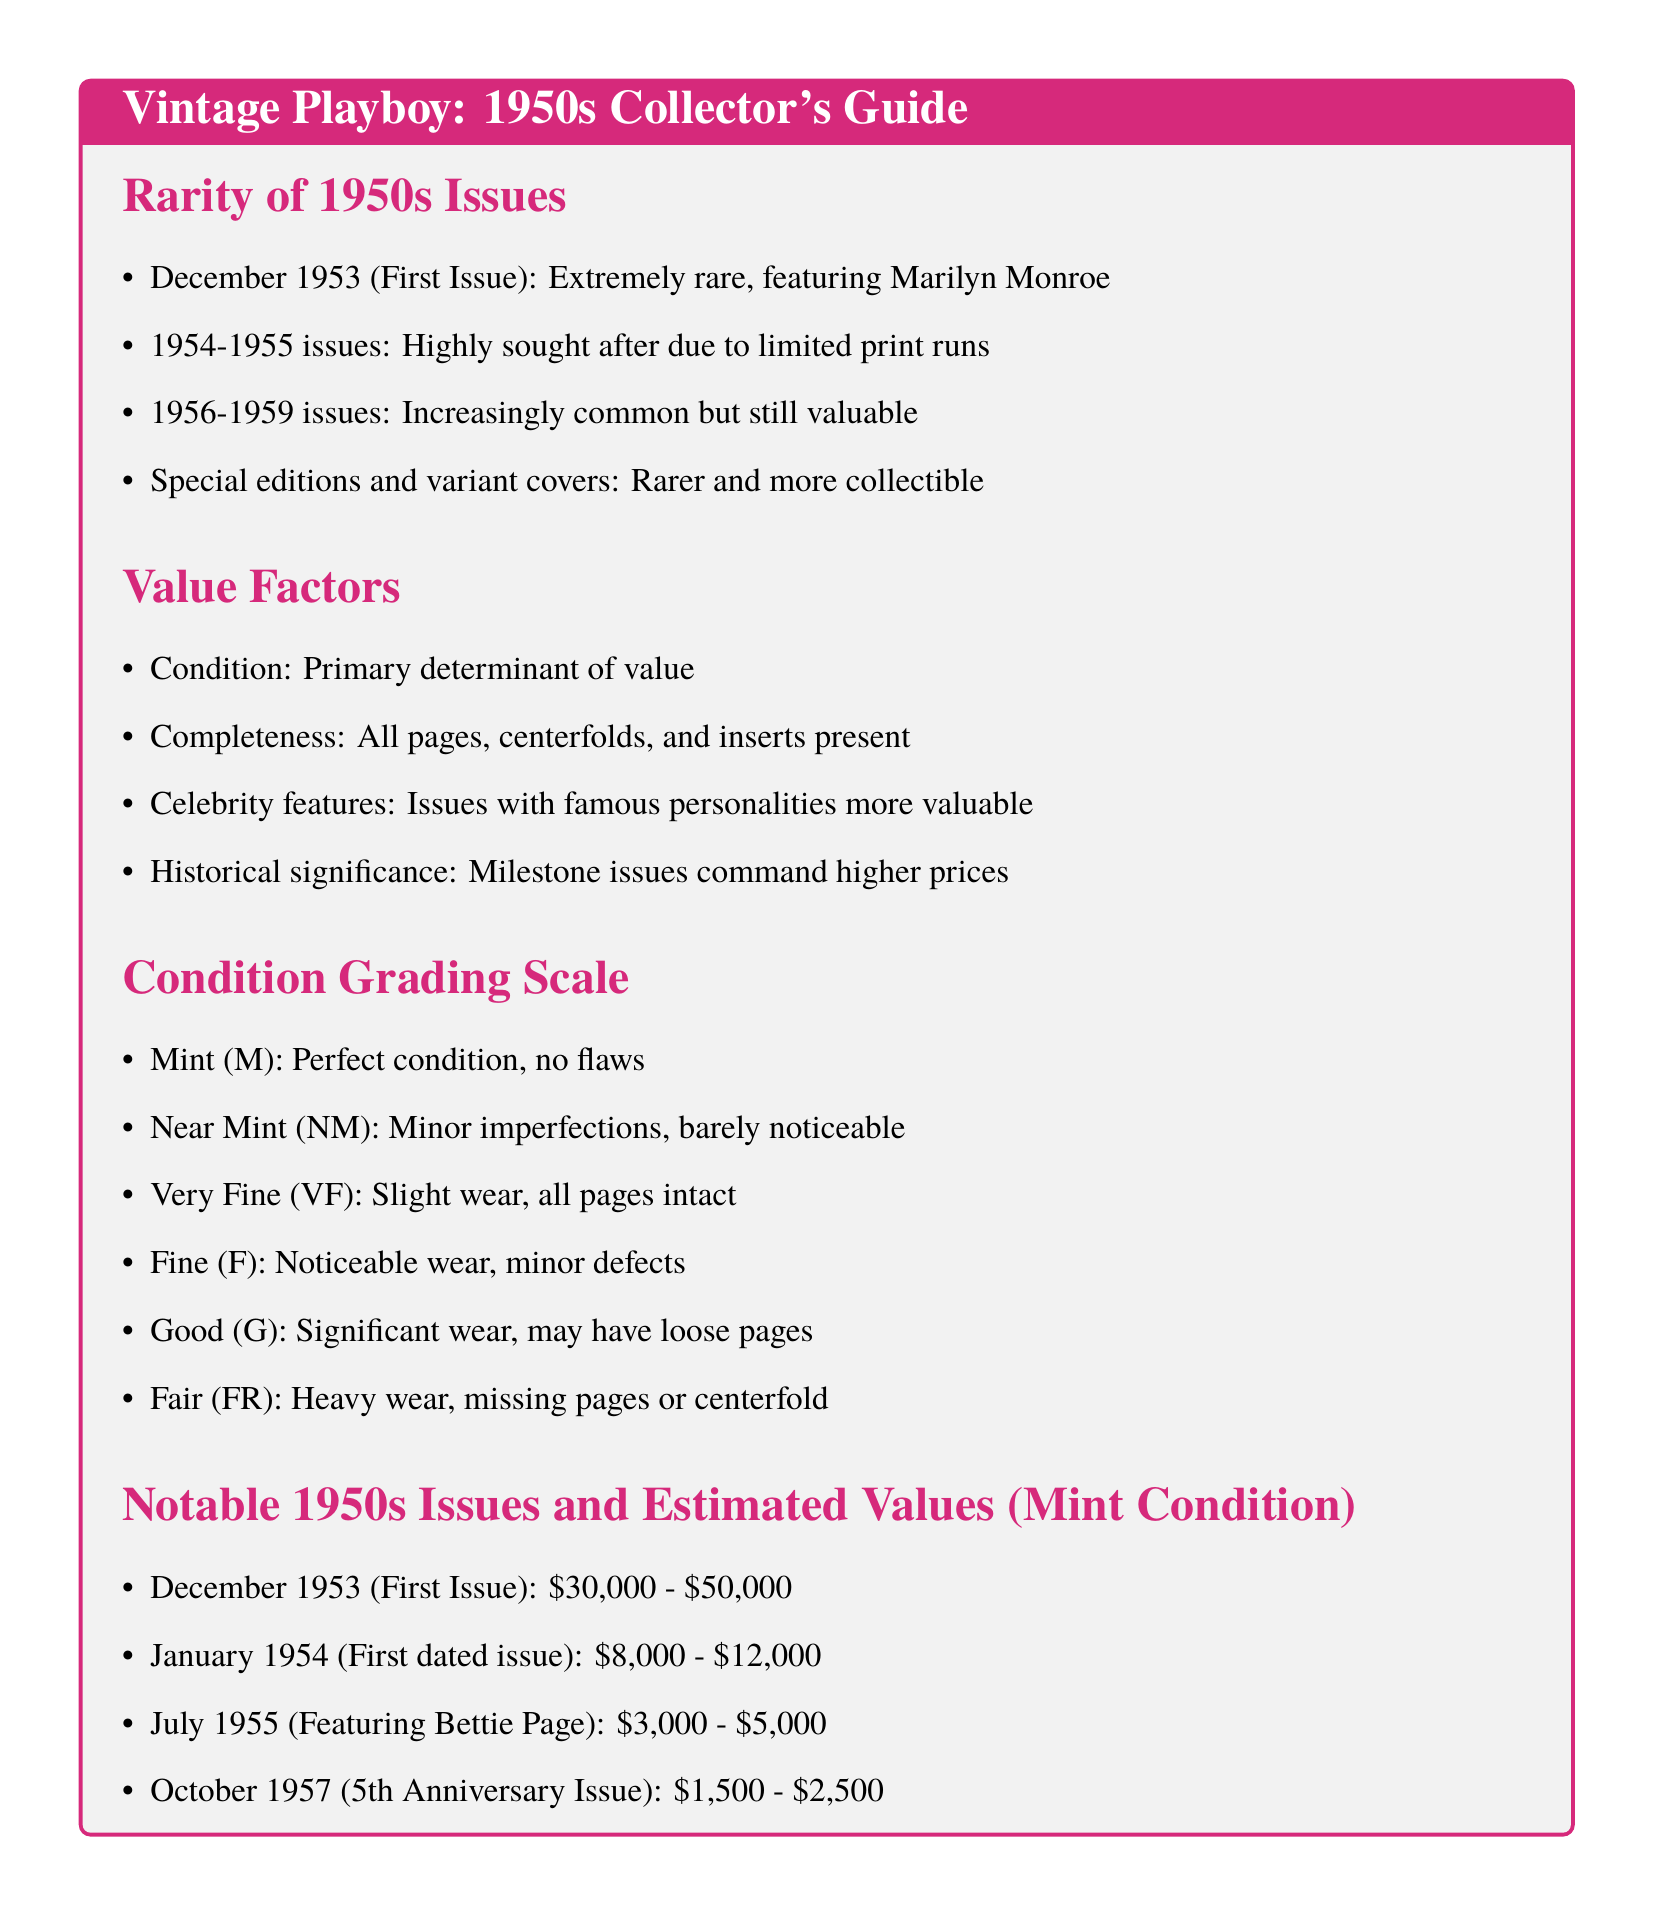What is the first issue of Playboy? The first issue of Playboy is the December 1953 issue, which is extremely rare and features Marilyn Monroe.
Answer: December 1953 What is the value range of the December 1953 issue in mint condition? The value range for the December 1953 issue in mint condition is estimated between $30,000 and $50,000.
Answer: $30,000 - $50,000 What condition does "Good (G)" represent in terms of wear? "Good (G)" represents significant wear, with possible loose pages.
Answer: Significant wear Which issue features Bettie Page? The July 1955 issue features Bettie Page and is valued between $3,000 and $5,000.
Answer: July 1955 What is a key factor in determining the value of a 1950s Playboy magazine? Condition is the primary determinant of value.
Answer: Condition What grading represents perfect condition? Mint (M) represents perfect condition with no flaws.
Answer: Mint (M) Which decade does this document focus on for Playboy magazine collecting? The document focuses on the 1950s.
Answer: 1950s What is true about the 1954-1955 issues? The 1954-1955 issues are highly sought after due to limited print runs.
Answer: Highly sought after How does historical significance affect the value? Milestone issues command higher prices due to their historical significance.
Answer: Higher prices 